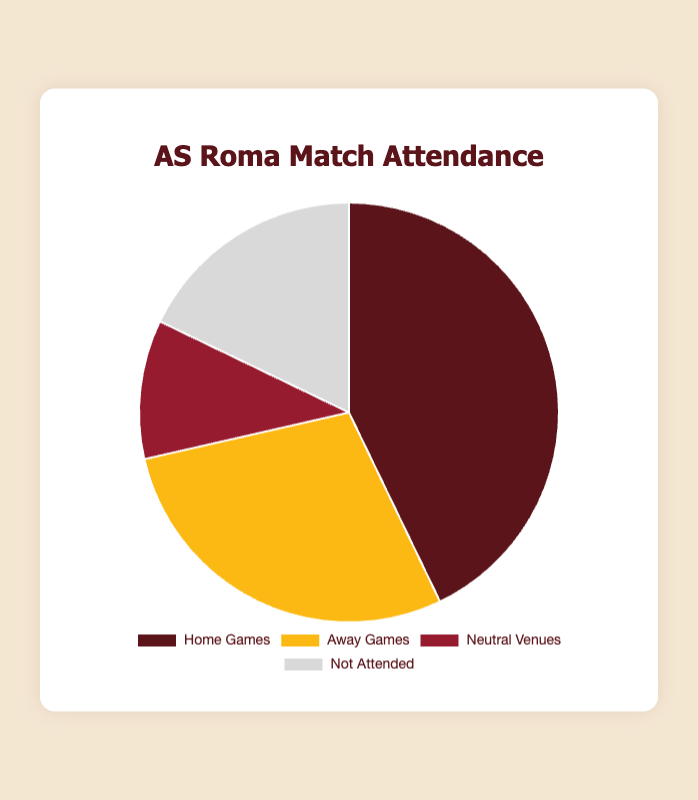What percentage of matches attended were home games? To find the percentage, divide the number of home games attended (12) by the total number of matches attended (12 + 8 + 3 + 5 = 28), then multiply by 100. (12 / 28) * 100 = 42.86%
Answer: 42.86% Which type of match attendance has the least number of matches? The data shows home games (12), away games (8), neutral venues (3), and not attended (5). The category with the least number of matches is neutral venues with 3 matches.
Answer: Neutral Venues How many more home games were attended than away games? Subtract the number of away games attended (8) from the number of home games attended (12). 12 - 8 = 4
Answer: 4 How does the number of matches not attended compare to the number of neutral venue matches? Compare 5 (not attended) with 3 (neutral venues). Not attended matches (5) are more than neutral venues (3).
Answer: More What is the total number of matches attended (excluding those not attended)? Add the number of home games (12), away games (8), and neutral venues (3). 12 + 8 + 3 = 23
Answer: 23 Which type of match attendance represents the largest segment in the pie chart and what does it indicate? The type with the largest segment is home games, which indicates the highest number of matches attended are home games (12).
Answer: Home Games What is the ratio of home games attended to total matches attended? Divide home games attended (12) by total matches attended (28). 12 / 28 = 3 / 7 (simplified)
Answer: 3:7 Which segment of the pie chart would be represented with the color red? Observing the chart's color scheme, red represents the "Home Games" section, which is the largest segment.
Answer: Home Games How many matches were attended in neutral venues and not attended combined? Add the number of neutral venue matches (3) to not attended matches (5). 3 + 5 = 8
Answer: 8 If the total number of matches is 28, what proportion of the matches were away games? Divide the number of away games (8) by the total number of matches (28). 8 / 28 = 2 / 7 (simplified)
Answer: 2:7 